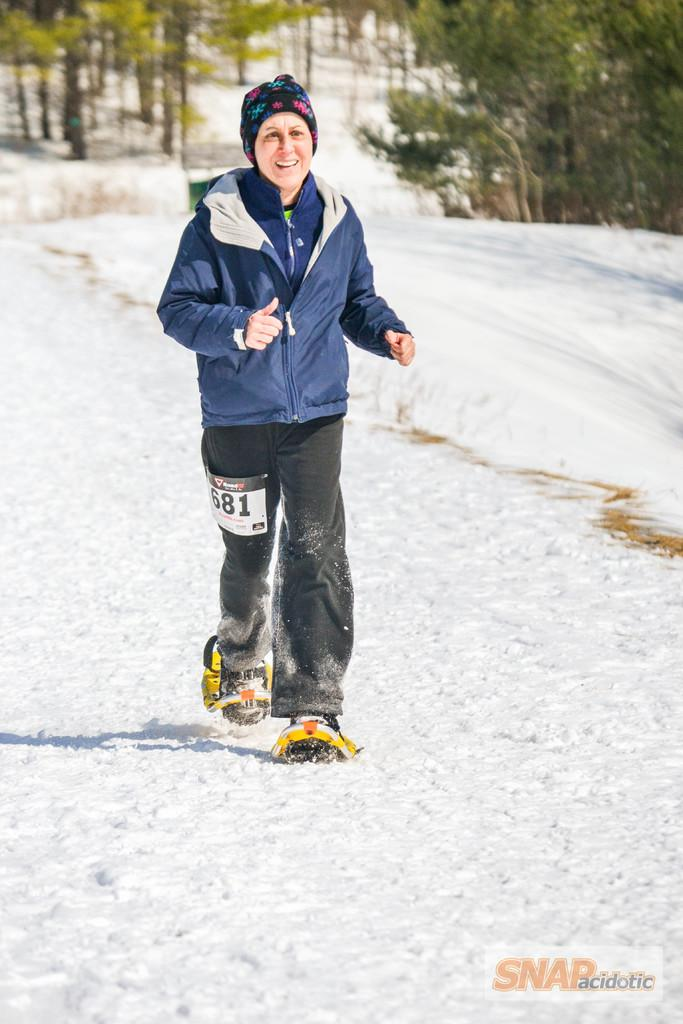What is the main subject of the image? There is a person in the image. What is the person wearing? The person is wearing a blue jacket. What activity is the person engaged in? The person is running on the snow. What type of footwear is the person wearing? The person is wearing snowshoes. What can be seen in the background of the image? There are trees in the background of the image. What type of crate can be seen in the image? There is no crate present in the image. What type of badge is the person wearing in the image? There is no badge visible on the person in the image. 